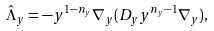Convert formula to latex. <formula><loc_0><loc_0><loc_500><loc_500>\hat { \Lambda } _ { y } = - y ^ { 1 - n _ { y } } \nabla _ { y } ( D _ { y } y ^ { n _ { y } - 1 } \nabla _ { y } ) ,</formula> 